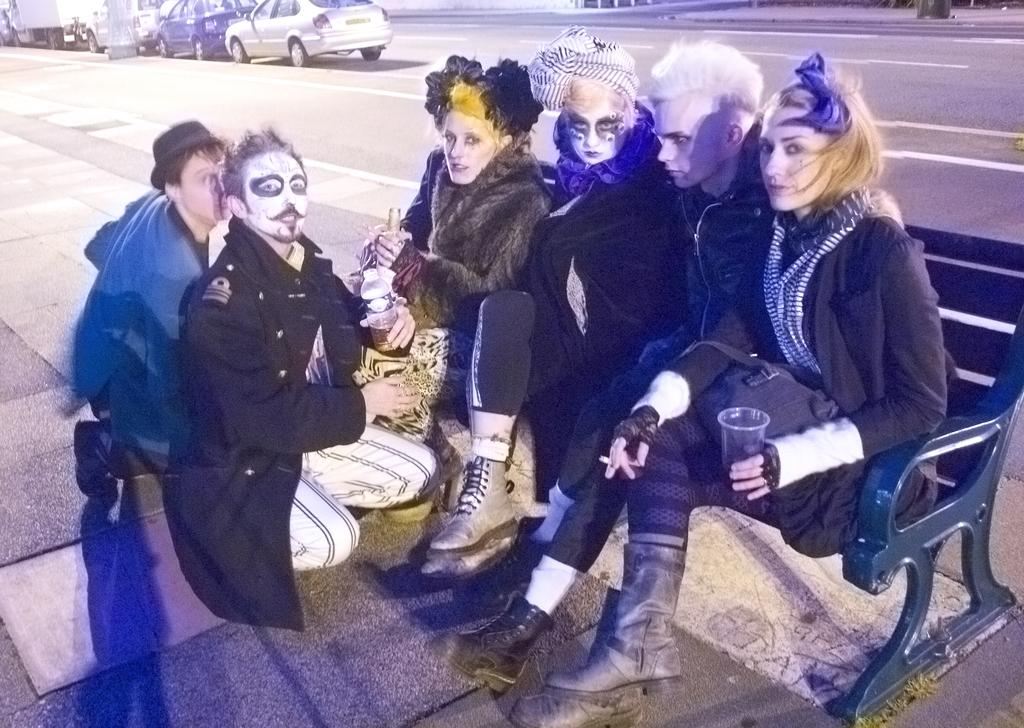What is happening in the foreground of the image? There is a group of people in the foreground of the image. What can be observed about the appearance of the people? The people have paint on their faces. What type of man-made structure can be seen in the image? There is a road visible in the image. What is located on the left side of the image? There are vehicles on the left side of the image. Where is the maid in the image? There is no maid present in the image. What type of furniture can be seen in the bedroom in the image? There is no bedroom present in the image. 